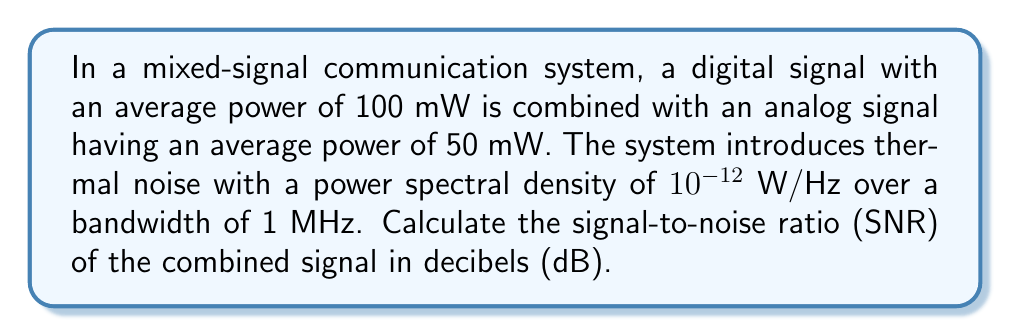Can you solve this math problem? To solve this problem, we'll follow these steps:

1) Calculate the total signal power:
   $$P_{signal} = P_{digital} + P_{analog} = 100 \text{ mW} + 50 \text{ mW} = 150 \text{ mW}$$

2) Calculate the noise power:
   The noise power is given by the noise power spectral density multiplied by the bandwidth.
   $$P_{noise} = N_0 \cdot B = 10^{-12} \text{ W/Hz} \cdot 10^6 \text{ Hz} = 10^{-6} \text{ W} = 1 \text{ µW}$$

3) Calculate the SNR:
   $$\text{SNR} = \frac{P_{signal}}{P_{noise}} = \frac{150 \text{ mW}}{1 \text{ µW}} = \frac{150 \cdot 10^{-3}}{1 \cdot 10^{-6}} = 150,000$$

4) Convert the SNR to decibels:
   $$\text{SNR}_{\text{dB}} = 10 \log_{10}(\text{SNR}) = 10 \log_{10}(150,000) \approx 51.76 \text{ dB}$$
Answer: 51.76 dB 